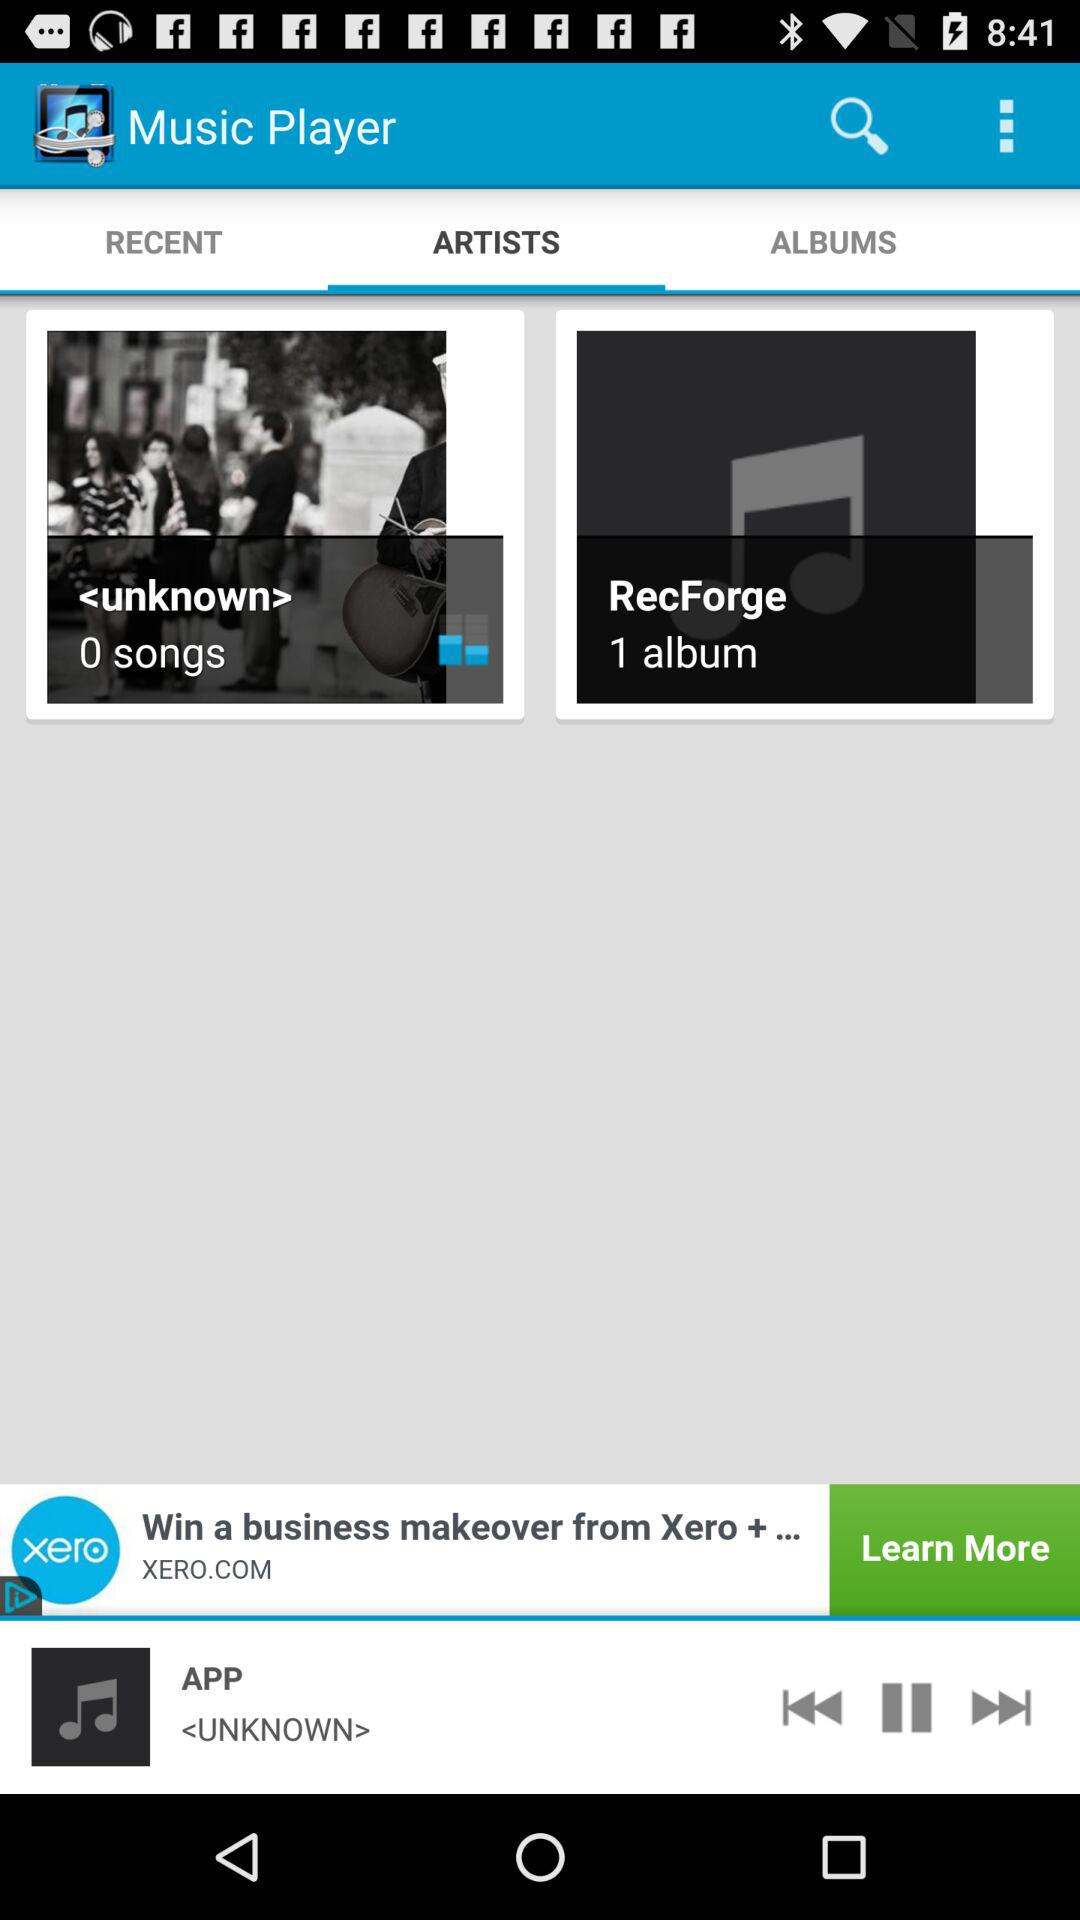What is the name of the currently playing album? The currently playing album is "APP". 